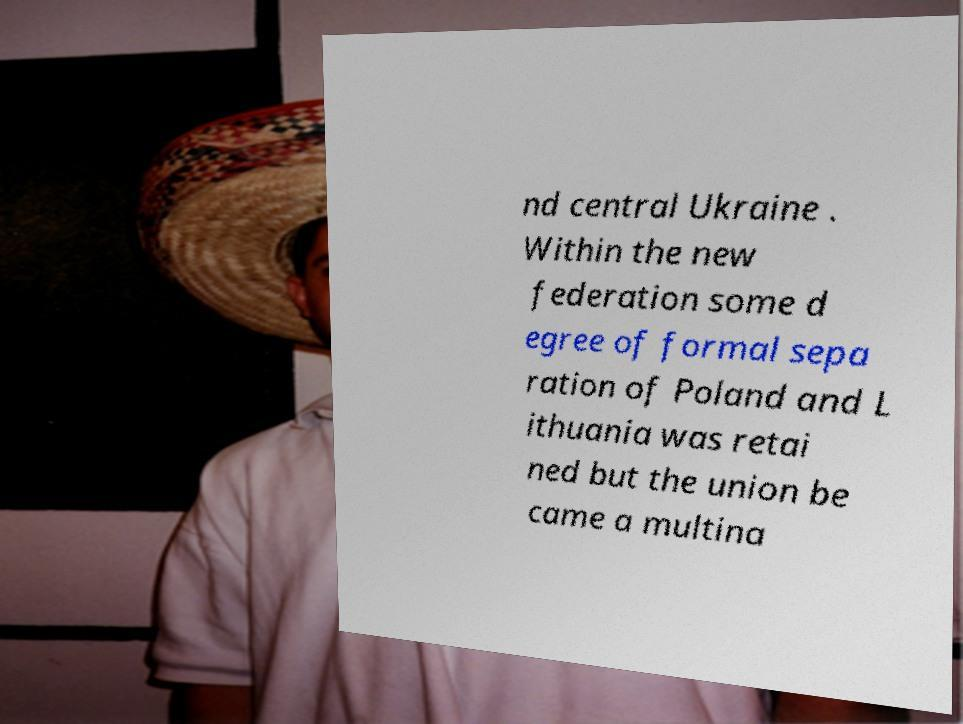Can you read and provide the text displayed in the image?This photo seems to have some interesting text. Can you extract and type it out for me? nd central Ukraine . Within the new federation some d egree of formal sepa ration of Poland and L ithuania was retai ned but the union be came a multina 